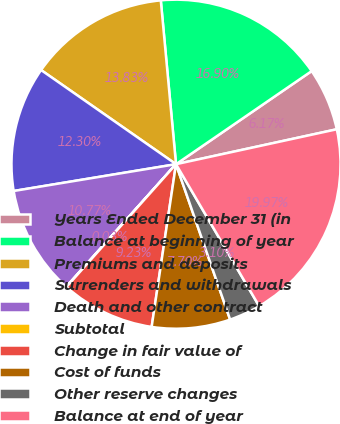Convert chart to OTSL. <chart><loc_0><loc_0><loc_500><loc_500><pie_chart><fcel>Years Ended December 31 (in<fcel>Balance at beginning of year<fcel>Premiums and deposits<fcel>Surrenders and withdrawals<fcel>Death and other contract<fcel>Subtotal<fcel>Change in fair value of<fcel>Cost of funds<fcel>Other reserve changes<fcel>Balance at end of year<nl><fcel>6.17%<fcel>16.9%<fcel>13.83%<fcel>12.3%<fcel>10.77%<fcel>0.03%<fcel>9.23%<fcel>7.7%<fcel>3.1%<fcel>19.97%<nl></chart> 